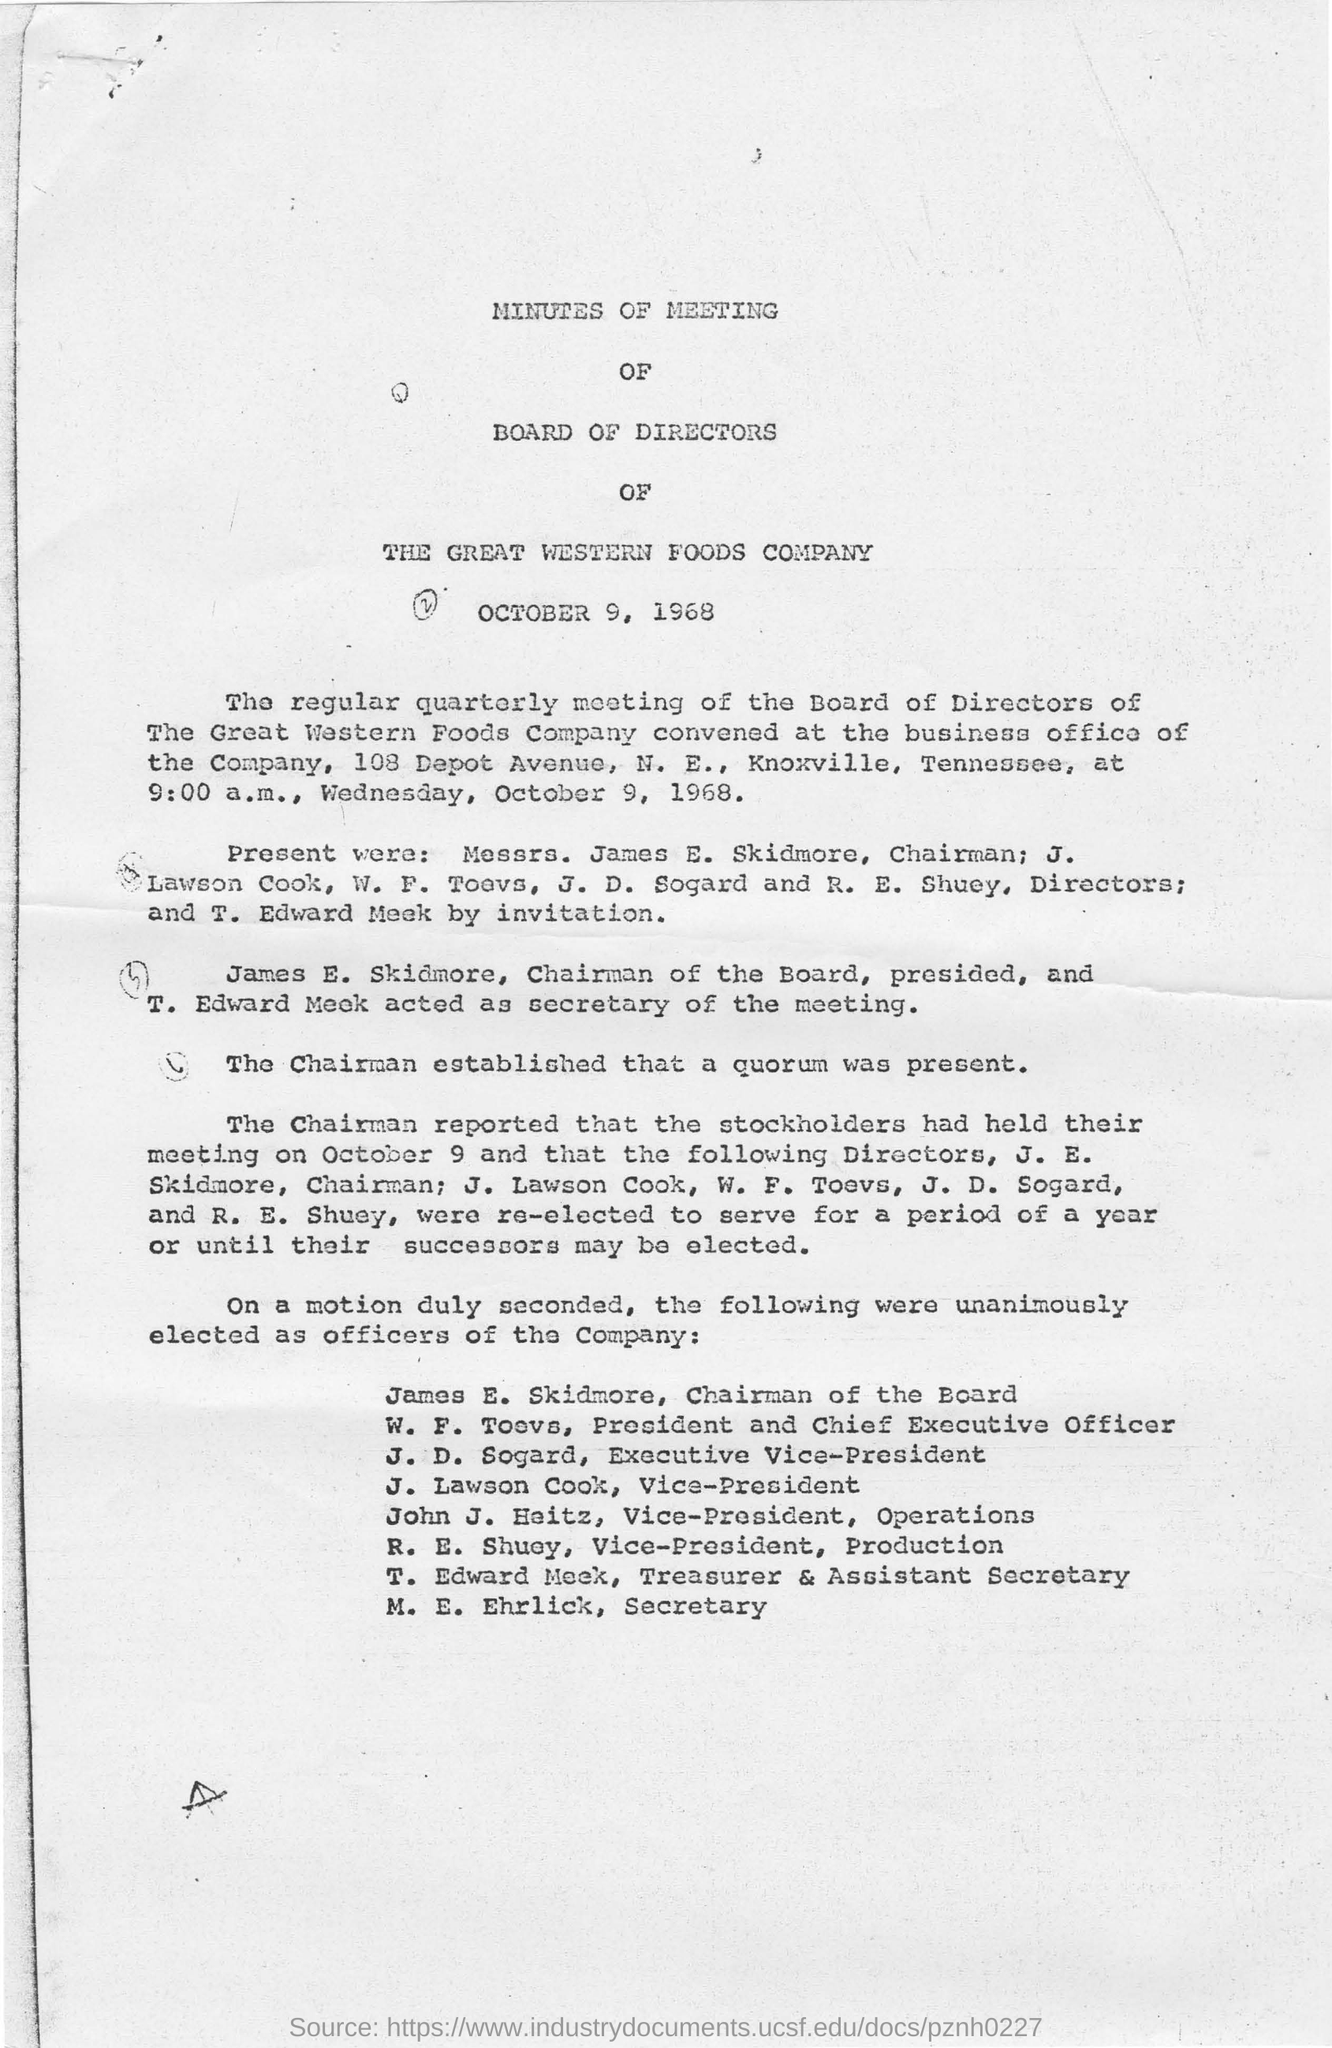Which company's board of directors of minutes of meeting?
Provide a succinct answer. THE GREAT WESTERN FOODS COMPANY. When board of directors of minutes of meeting is conducted?
Give a very brief answer. October 9, 1968. Where is the regular board of directors of the great western foods company  convened?
Offer a very short reply. At the business office of the company,. What is the address of the business office of the company?
Offer a terse response. 108 Depot Avenue, N. E., Knoxville, Tennessee. Who is the secretary of the meeting?
Your answer should be compact. T. Edward Meek. Who are unanimously elected for the vice president?
Ensure brevity in your answer.  J. Lawson Cook. Who are unanimously elected for the  secretary?
Your answer should be compact. M. E. EHRLICK. Who are unanimously elected for chairman of the board ?
Your answer should be compact. James E. Skidmore. 